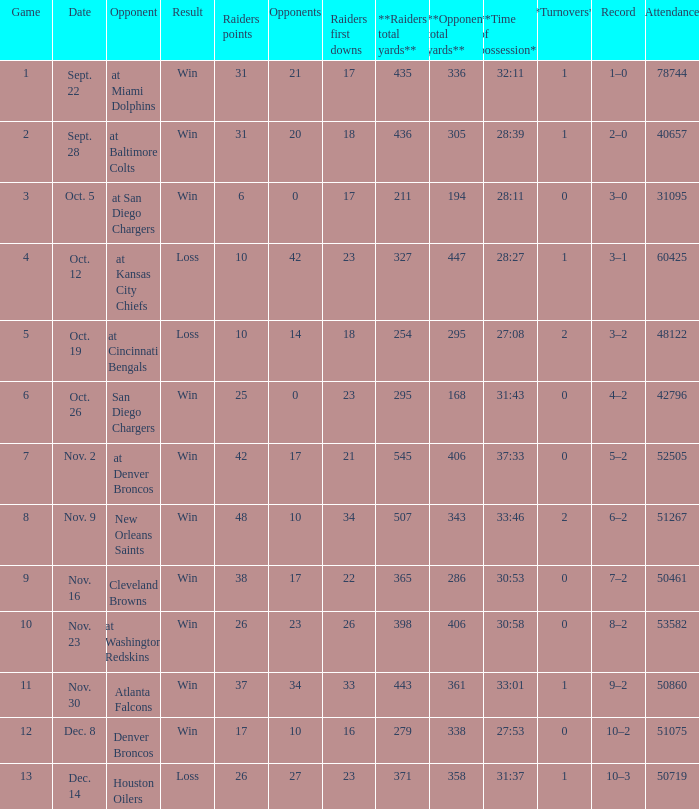Who was the game attended by 60425 people played against? At kansas city chiefs. 